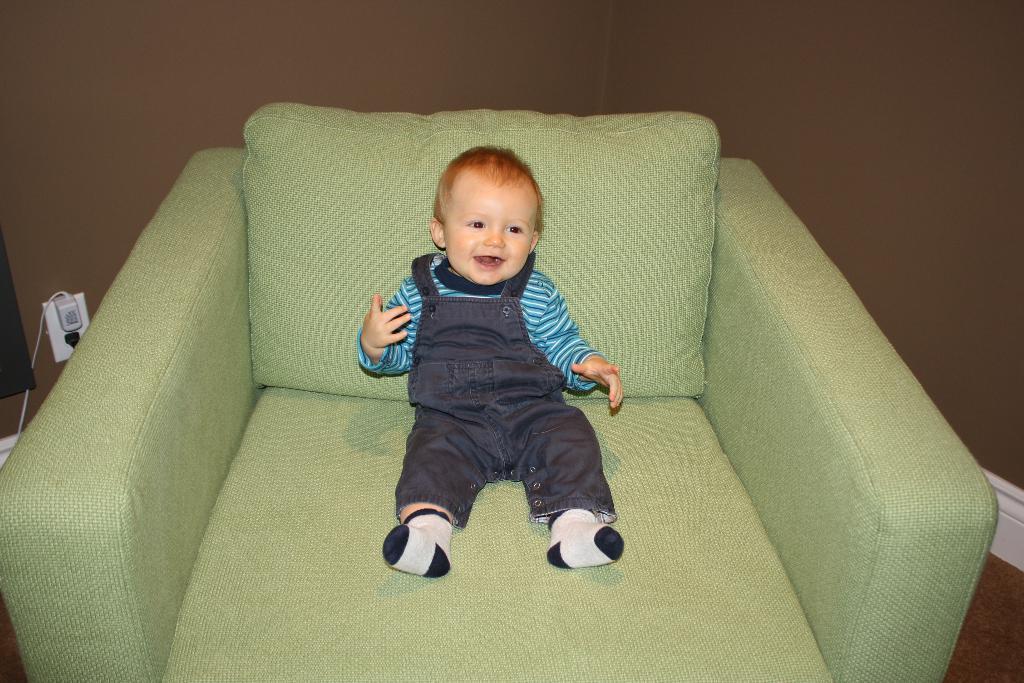Can you describe this image briefly? In this image a baby is sitting in a sofa and wearing blue shirt, brown pants, black and white socks. In the background there is wall, to the left there is a switch board. 